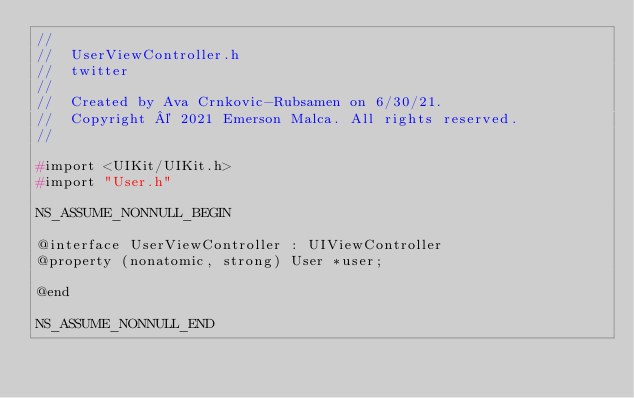Convert code to text. <code><loc_0><loc_0><loc_500><loc_500><_C_>//
//  UserViewController.h
//  twitter
//
//  Created by Ava Crnkovic-Rubsamen on 6/30/21.
//  Copyright © 2021 Emerson Malca. All rights reserved.
//

#import <UIKit/UIKit.h>
#import "User.h"

NS_ASSUME_NONNULL_BEGIN

@interface UserViewController : UIViewController
@property (nonatomic, strong) User *user;

@end

NS_ASSUME_NONNULL_END
</code> 